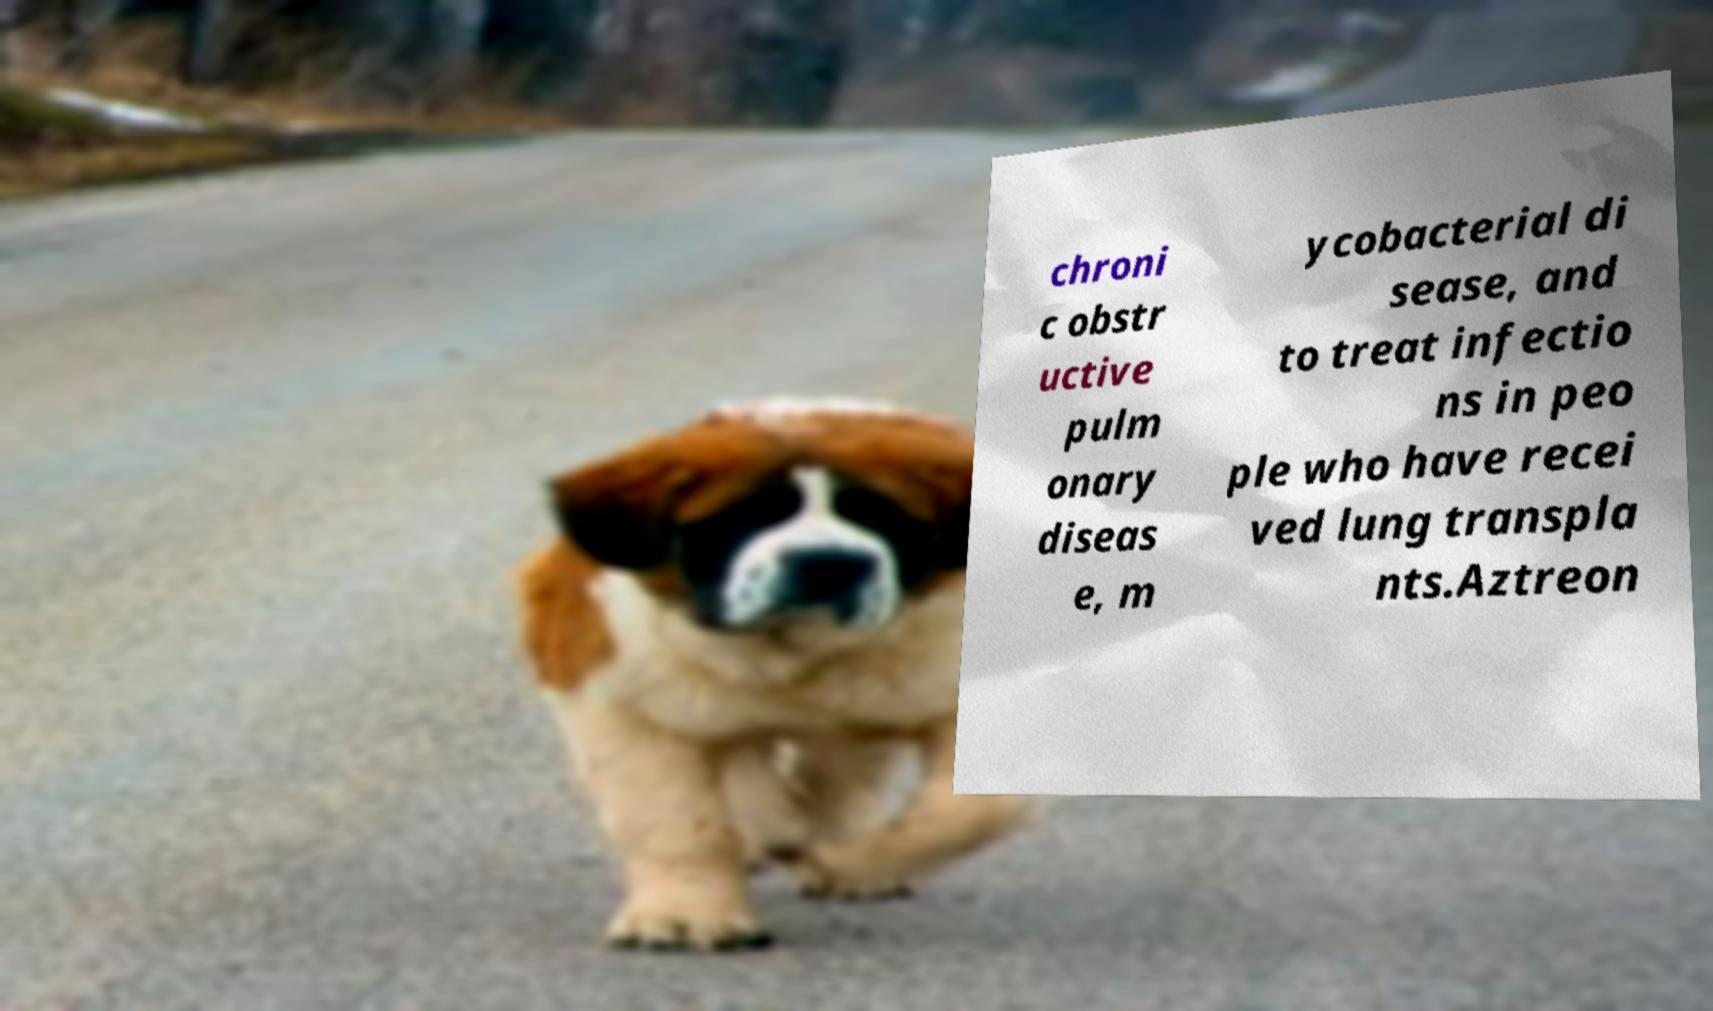Could you extract and type out the text from this image? chroni c obstr uctive pulm onary diseas e, m ycobacterial di sease, and to treat infectio ns in peo ple who have recei ved lung transpla nts.Aztreon 